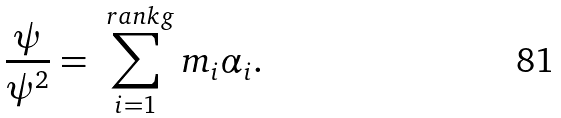<formula> <loc_0><loc_0><loc_500><loc_500>\frac { \psi } { { \psi } ^ { 2 } } = \sum _ { i = 1 } ^ { \ r a n k g } m _ { i } { \alpha } _ { i } .</formula> 